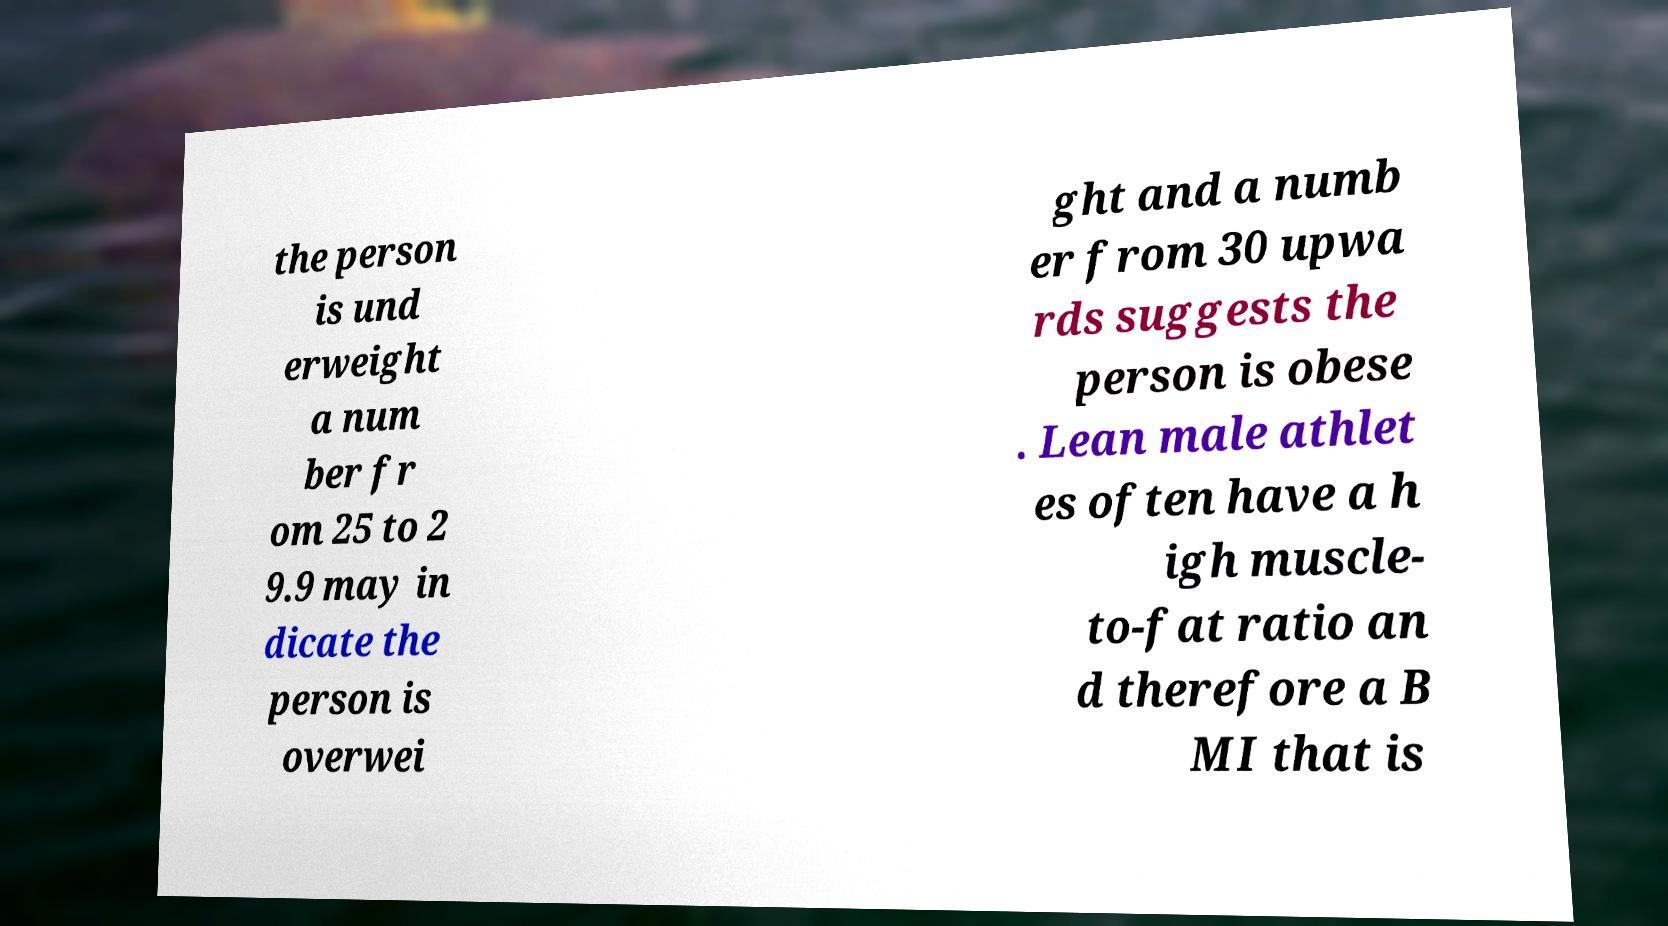What messages or text are displayed in this image? I need them in a readable, typed format. the person is und erweight a num ber fr om 25 to 2 9.9 may in dicate the person is overwei ght and a numb er from 30 upwa rds suggests the person is obese . Lean male athlet es often have a h igh muscle- to-fat ratio an d therefore a B MI that is 